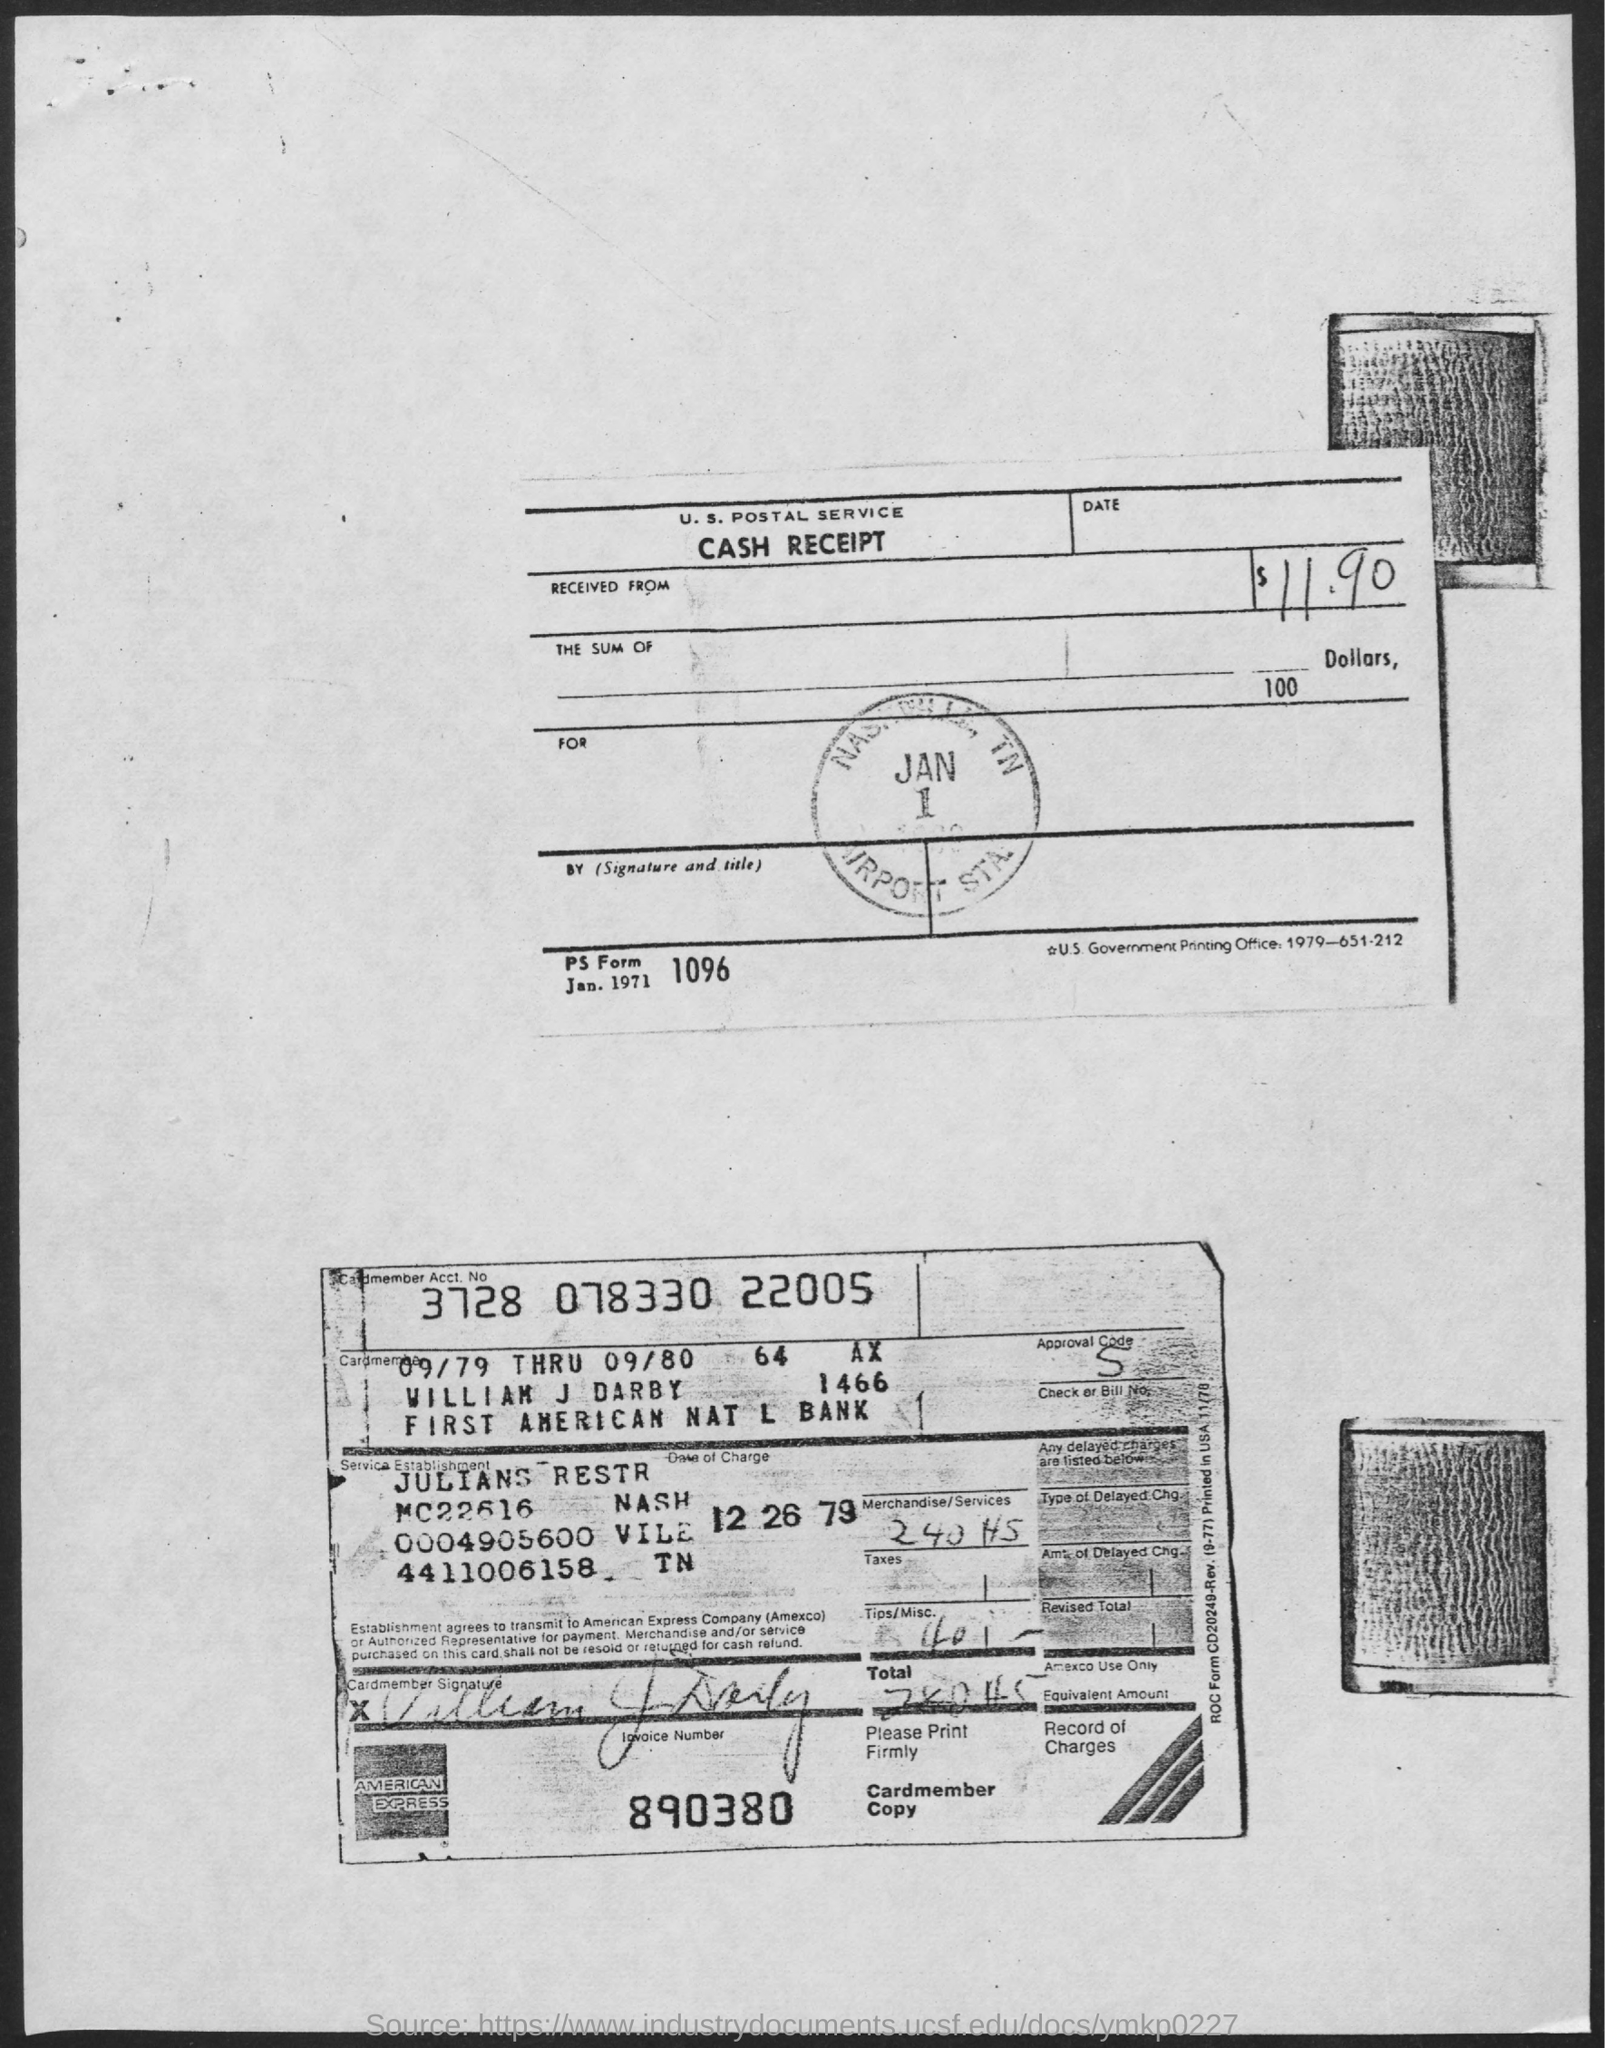List a handful of essential elements in this visual. The amount is $11.90. The title of the document is "Cash Receipt..". 